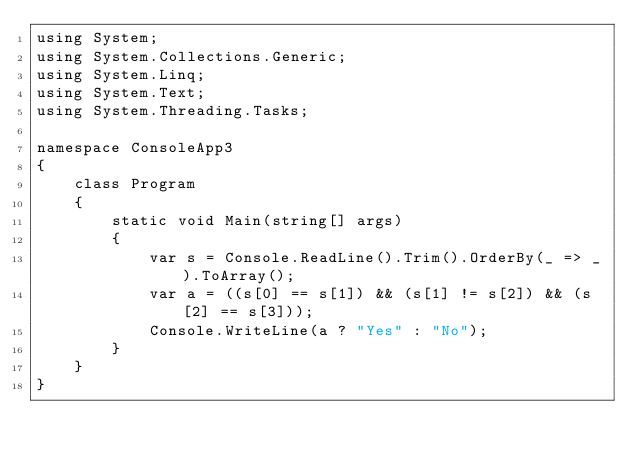<code> <loc_0><loc_0><loc_500><loc_500><_C#_>using System;
using System.Collections.Generic;
using System.Linq;
using System.Text;
using System.Threading.Tasks;

namespace ConsoleApp3
{
    class Program
    {
        static void Main(string[] args)
        {
            var s = Console.ReadLine().Trim().OrderBy(_ => _).ToArray();
            var a = ((s[0] == s[1]) && (s[1] != s[2]) && (s[2] == s[3]));
            Console.WriteLine(a ? "Yes" : "No");
        }
    }
}
</code> 